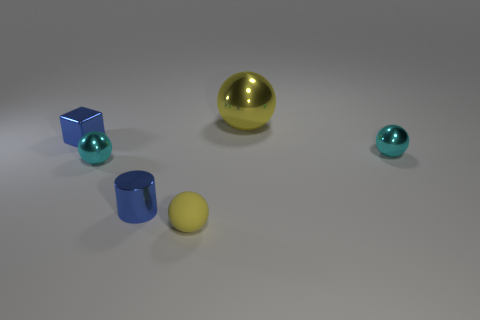Can you describe the arrangement and colors of the objects in the image? Certainly! In the image, we can see a large yellow sphere and a small yellow sphere placed towards the right. On the left, there's a blue cylinder and a blue cube, both with a smaller blue sphere in proximity. The arrangement seems random but encompasses vivid colors and different sizes, creating a visually pleasing composition. 